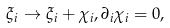<formula> <loc_0><loc_0><loc_500><loc_500>\xi _ { i } \to \xi _ { i } + \chi _ { i } , \partial _ { i } \chi _ { i } = 0 ,</formula> 